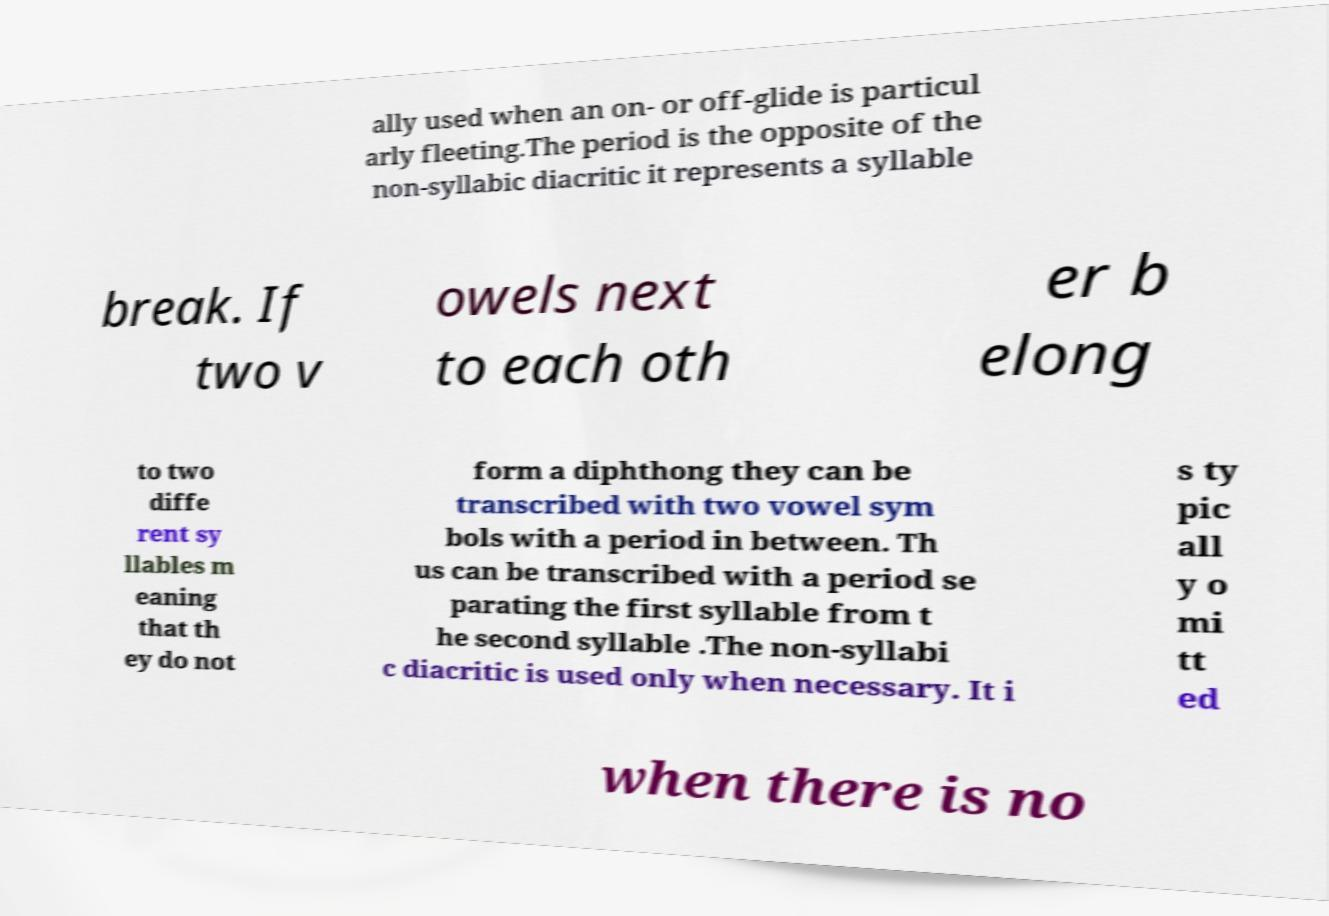Please read and relay the text visible in this image. What does it say? ally used when an on- or off-glide is particul arly fleeting.The period is the opposite of the non-syllabic diacritic it represents a syllable break. If two v owels next to each oth er b elong to two diffe rent sy llables m eaning that th ey do not form a diphthong they can be transcribed with two vowel sym bols with a period in between. Th us can be transcribed with a period se parating the first syllable from t he second syllable .The non-syllabi c diacritic is used only when necessary. It i s ty pic all y o mi tt ed when there is no 